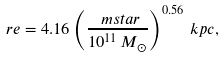Convert formula to latex. <formula><loc_0><loc_0><loc_500><loc_500>\ r e = 4 . 1 6 \left ( \frac { \ m s t a r } { 1 0 ^ { 1 1 } \, M _ { \odot } } \right ) ^ { 0 . 5 6 } \, k p c ,</formula> 